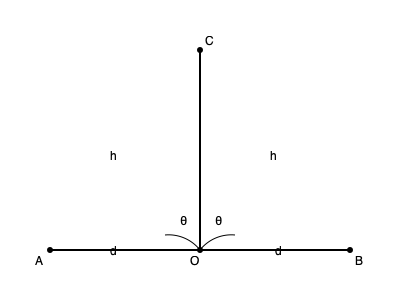On a television commercial set, you need to calculate the viewing angle for two cameras positioned at points A and B, both d meters away from the center point O, where the main actor stands. A third camera is placed directly above the actor at point C, at a height of h meters. What is the total viewing angle θ (in degrees) between the two ground cameras if d = 3 meters and h = 4 meters? To solve this problem, we'll use the following steps:

1) First, we need to recognize that we have two right triangles: AOC and BOC.

2) In each of these triangles, we can use the arctangent function to find half of the viewing angle θ.

3) The tangent of half the viewing angle is the ratio of the opposite side (d) to the adjacent side (h):

   $tan(\frac{\theta}{2}) = \frac{d}{h}$

4) Therefore, we can find θ/2 using the arctangent function:

   $\frac{\theta}{2} = arctan(\frac{d}{h})$

5) Substituting the given values:

   $\frac{\theta}{2} = arctan(\frac{3}{4})$

6) To get the full viewing angle, we multiply this by 2:

   $\theta = 2 * arctan(\frac{3}{4})$

7) Using a calculator or computer:

   $\theta = 2 * arctan(\frac{3}{4}) \approx 2 * 0.6435 \approx 1.2870$ radians

8) Convert radians to degrees:

   $\theta_{degrees} = \theta_{radians} * \frac{180}{\pi} \approx 1.2870 * \frac{180}{\pi} \approx 73.74$ degrees

Therefore, the total viewing angle between the two ground cameras is approximately 73.74 degrees.
Answer: 73.74° 